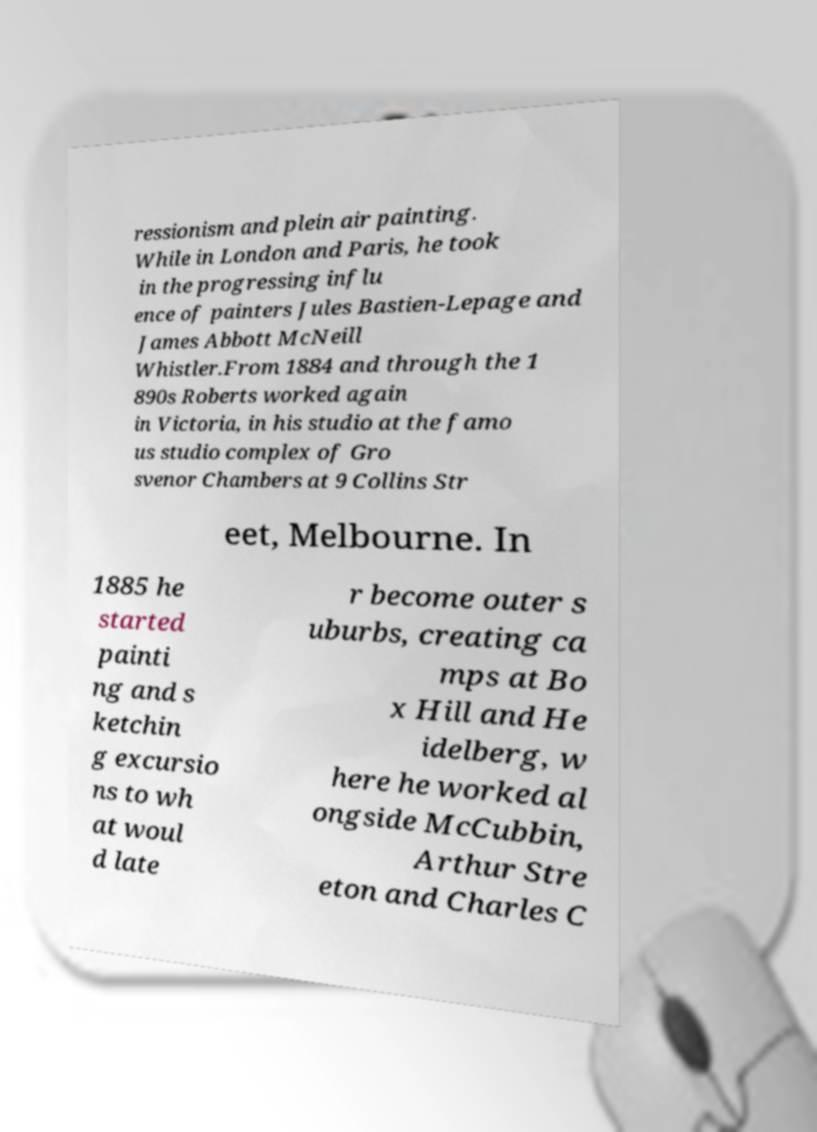Please read and relay the text visible in this image. What does it say? ressionism and plein air painting. While in London and Paris, he took in the progressing influ ence of painters Jules Bastien-Lepage and James Abbott McNeill Whistler.From 1884 and through the 1 890s Roberts worked again in Victoria, in his studio at the famo us studio complex of Gro svenor Chambers at 9 Collins Str eet, Melbourne. In 1885 he started painti ng and s ketchin g excursio ns to wh at woul d late r become outer s uburbs, creating ca mps at Bo x Hill and He idelberg, w here he worked al ongside McCubbin, Arthur Stre eton and Charles C 